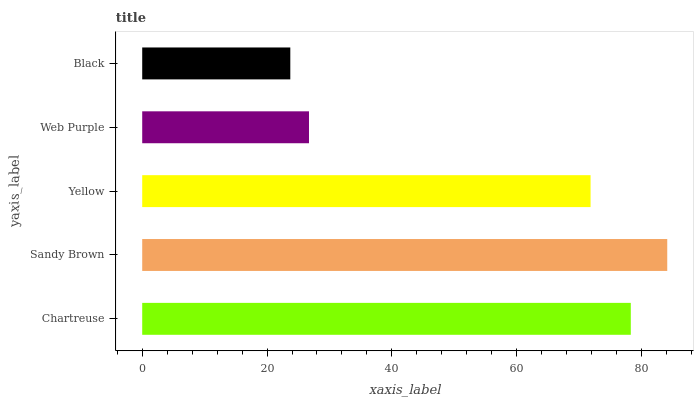Is Black the minimum?
Answer yes or no. Yes. Is Sandy Brown the maximum?
Answer yes or no. Yes. Is Yellow the minimum?
Answer yes or no. No. Is Yellow the maximum?
Answer yes or no. No. Is Sandy Brown greater than Yellow?
Answer yes or no. Yes. Is Yellow less than Sandy Brown?
Answer yes or no. Yes. Is Yellow greater than Sandy Brown?
Answer yes or no. No. Is Sandy Brown less than Yellow?
Answer yes or no. No. Is Yellow the high median?
Answer yes or no. Yes. Is Yellow the low median?
Answer yes or no. Yes. Is Black the high median?
Answer yes or no. No. Is Black the low median?
Answer yes or no. No. 